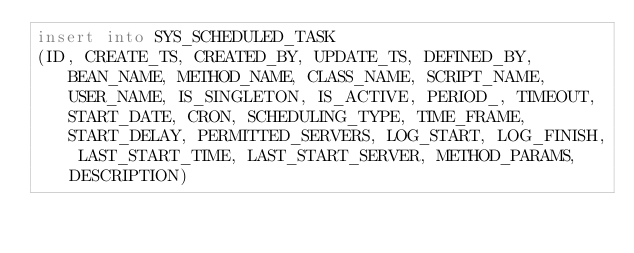<code> <loc_0><loc_0><loc_500><loc_500><_SQL_>insert into SYS_SCHEDULED_TASK
(ID, CREATE_TS, CREATED_BY, UPDATE_TS, DEFINED_BY, BEAN_NAME, METHOD_NAME, CLASS_NAME, SCRIPT_NAME, USER_NAME, IS_SINGLETON, IS_ACTIVE, PERIOD_, TIMEOUT, START_DATE, CRON, SCHEDULING_TYPE, TIME_FRAME, START_DELAY, PERMITTED_SERVERS, LOG_START, LOG_FINISH, LAST_START_TIME, LAST_START_SERVER, METHOD_PARAMS, DESCRIPTION)</code> 